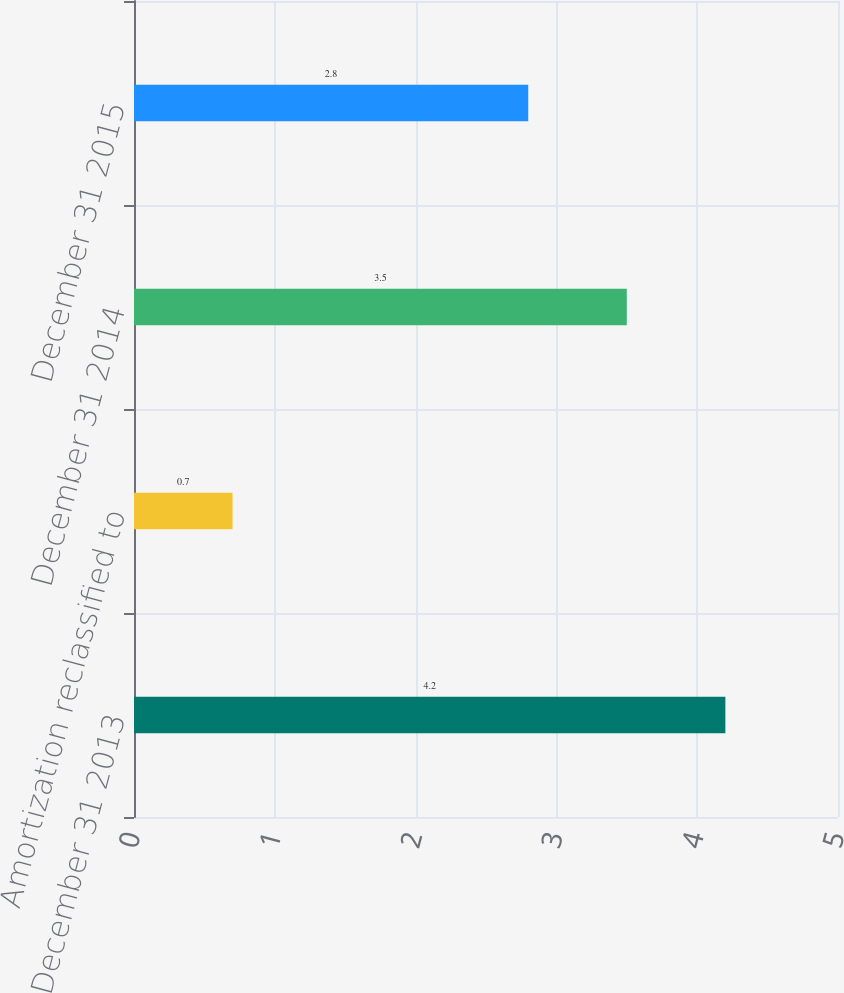<chart> <loc_0><loc_0><loc_500><loc_500><bar_chart><fcel>December 31 2013<fcel>Amortization reclassified to<fcel>December 31 2014<fcel>December 31 2015<nl><fcel>4.2<fcel>0.7<fcel>3.5<fcel>2.8<nl></chart> 